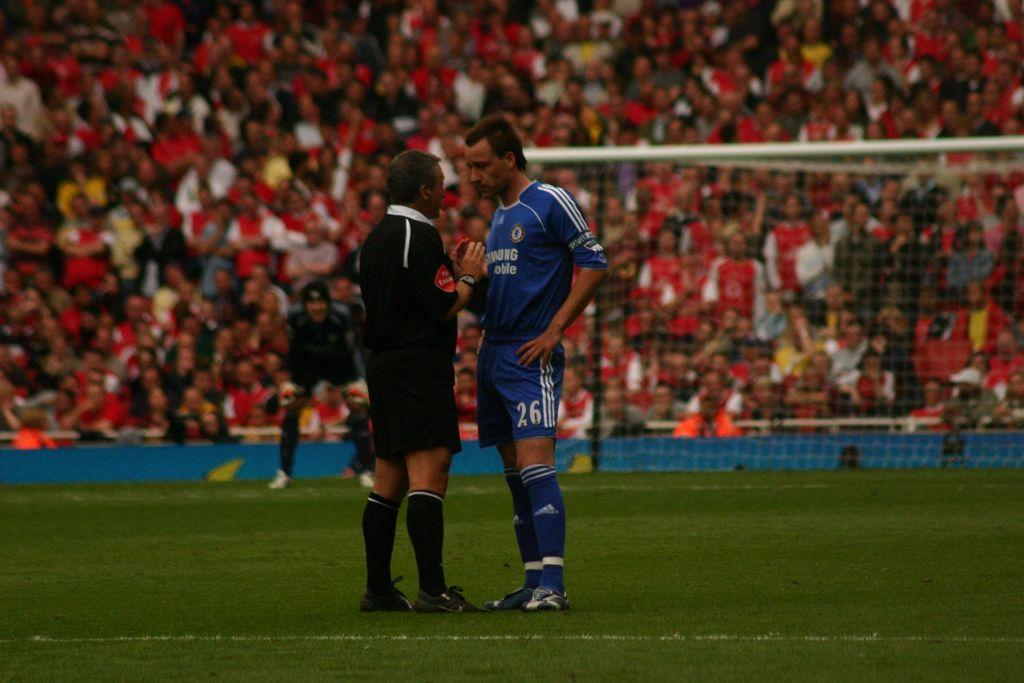How many people are standing on the grass in the image? There are three persons standing on the grass in the image. What is the audience doing in the image? The audience is sitting and watching a game. What type of jar can be seen floating down the stream in the image? There is no jar or stream present in the image; it features three persons standing on the grass and an audience watching a game. 